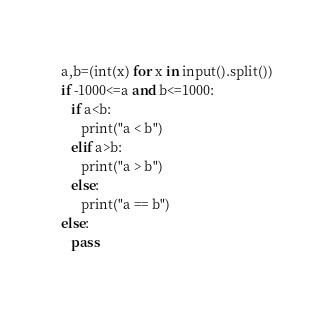Convert code to text. <code><loc_0><loc_0><loc_500><loc_500><_Python_>a,b=(int(x) for x in input().split())
if -1000<=a and b<=1000:
   if a<b:
      print("a < b")
   elif a>b:
      print("a > b")
   else:
      print("a == b")
else:
   pass
</code> 